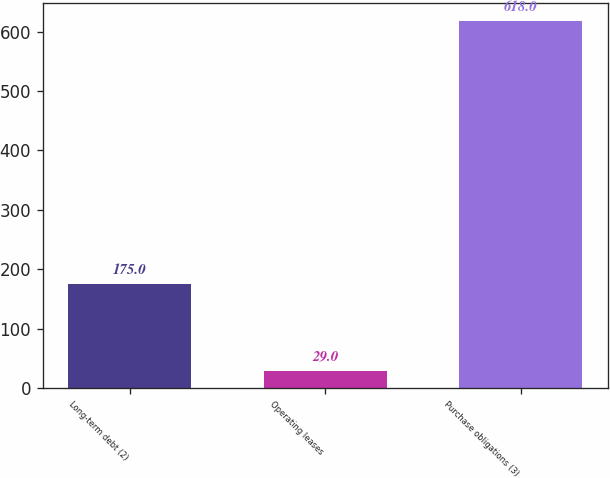Convert chart. <chart><loc_0><loc_0><loc_500><loc_500><bar_chart><fcel>Long-term debt (2)<fcel>Operating leases<fcel>Purchase obligations (3)<nl><fcel>175<fcel>29<fcel>618<nl></chart> 